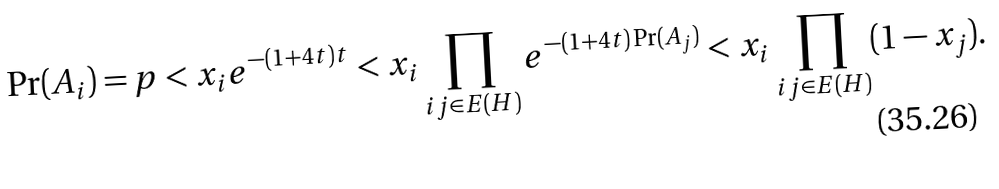<formula> <loc_0><loc_0><loc_500><loc_500>\Pr ( A _ { i } ) = p < x _ { i } e ^ { - ( 1 + 4 t ) t } < x _ { i } \prod _ { i j \in E ( H ) } e ^ { - ( 1 + 4 t ) \Pr ( A _ { j } ) } < x _ { i } \prod _ { i j \in E ( H ) } ( 1 - x _ { j } ) .</formula> 